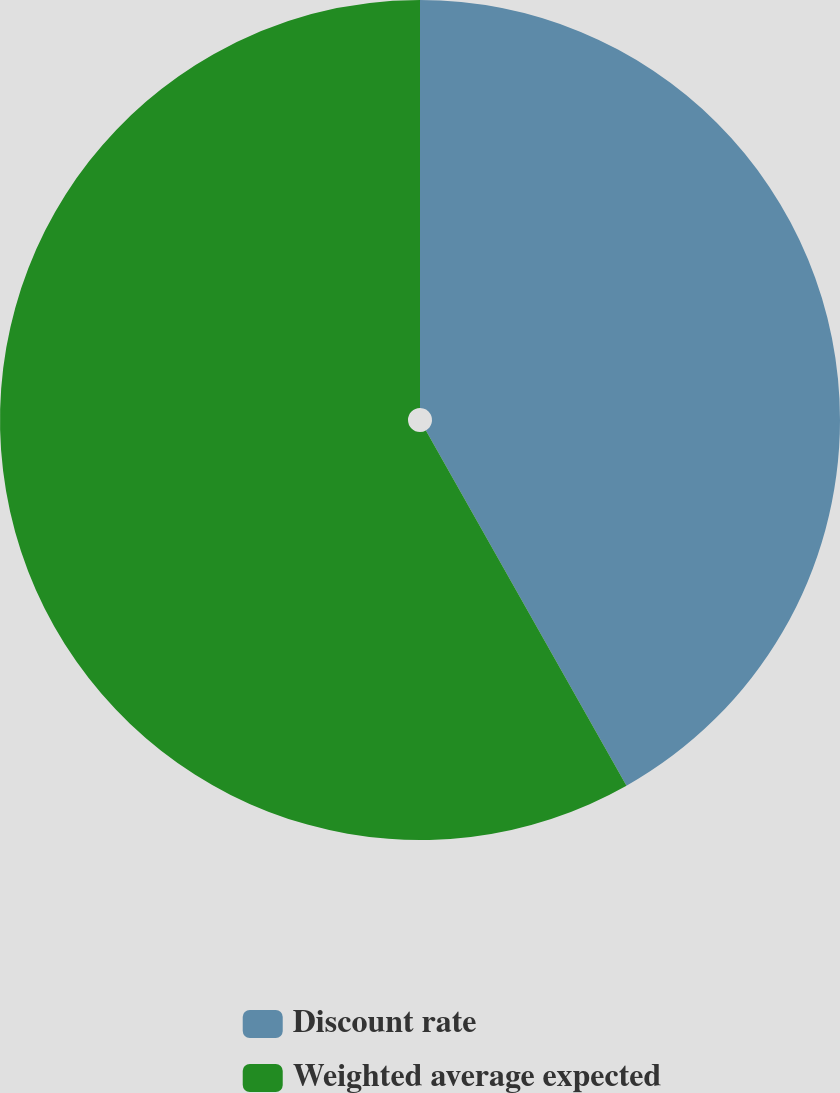<chart> <loc_0><loc_0><loc_500><loc_500><pie_chart><fcel>Discount rate<fcel>Weighted average expected<nl><fcel>41.82%<fcel>58.18%<nl></chart> 